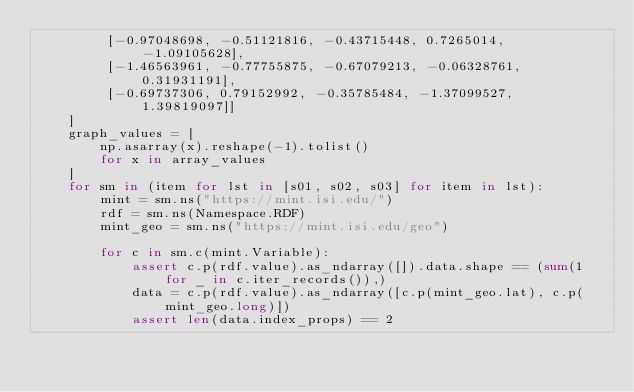Convert code to text. <code><loc_0><loc_0><loc_500><loc_500><_Python_>         [-0.97048698, -0.51121816, -0.43715448, 0.7265014, -1.09105628],
         [-1.46563961, -0.77755875, -0.67079213, -0.06328761, 0.31931191],
         [-0.69737306, 0.79152992, -0.35785484, -1.37099527, 1.39819097]]
    ]
    graph_values = [
        np.asarray(x).reshape(-1).tolist()
        for x in array_values
    ]
    for sm in (item for lst in [s01, s02, s03] for item in lst):
        mint = sm.ns("https://mint.isi.edu/")
        rdf = sm.ns(Namespace.RDF)
        mint_geo = sm.ns("https://mint.isi.edu/geo")

        for c in sm.c(mint.Variable):
            assert c.p(rdf.value).as_ndarray([]).data.shape == (sum(1 for _ in c.iter_records()),)
            data = c.p(rdf.value).as_ndarray([c.p(mint_geo.lat), c.p(mint_geo.long)])
            assert len(data.index_props) == 2
</code> 